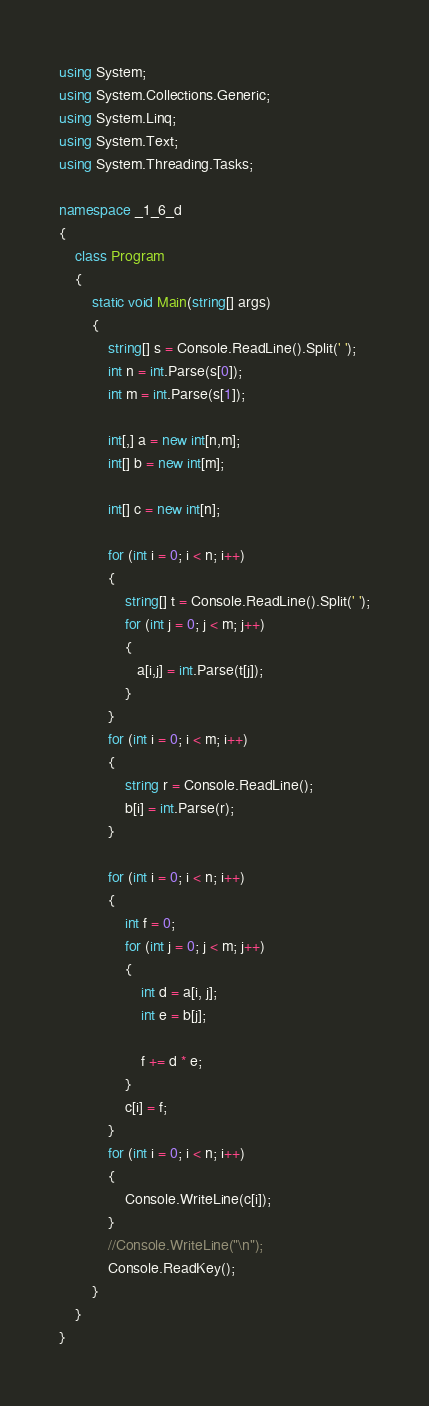Convert code to text. <code><loc_0><loc_0><loc_500><loc_500><_C#_>using System;
using System.Collections.Generic;
using System.Linq;
using System.Text;
using System.Threading.Tasks;

namespace _1_6_d
{
    class Program
    {
        static void Main(string[] args)
        {
            string[] s = Console.ReadLine().Split(' ');
            int n = int.Parse(s[0]);
            int m = int.Parse(s[1]);

            int[,] a = new int[n,m];
            int[] b = new int[m];

            int[] c = new int[n];

            for (int i = 0; i < n; i++)
            {
                string[] t = Console.ReadLine().Split(' ');
                for (int j = 0; j < m; j++)
                {
                   a[i,j] = int.Parse(t[j]);
                }
            }
            for (int i = 0; i < m; i++)
            {
                string r = Console.ReadLine();
                b[i] = int.Parse(r);
            }

            for (int i = 0; i < n; i++)
            {
                int f = 0;
                for (int j = 0; j < m; j++)
                {
                    int d = a[i, j];
                    int e = b[j];

                    f += d * e;
                }
                c[i] = f;
            }
            for (int i = 0; i < n; i++)
            {
                Console.WriteLine(c[i]);
            }
            //Console.WriteLine("\n");
            Console.ReadKey();
        }
    }
}

</code> 